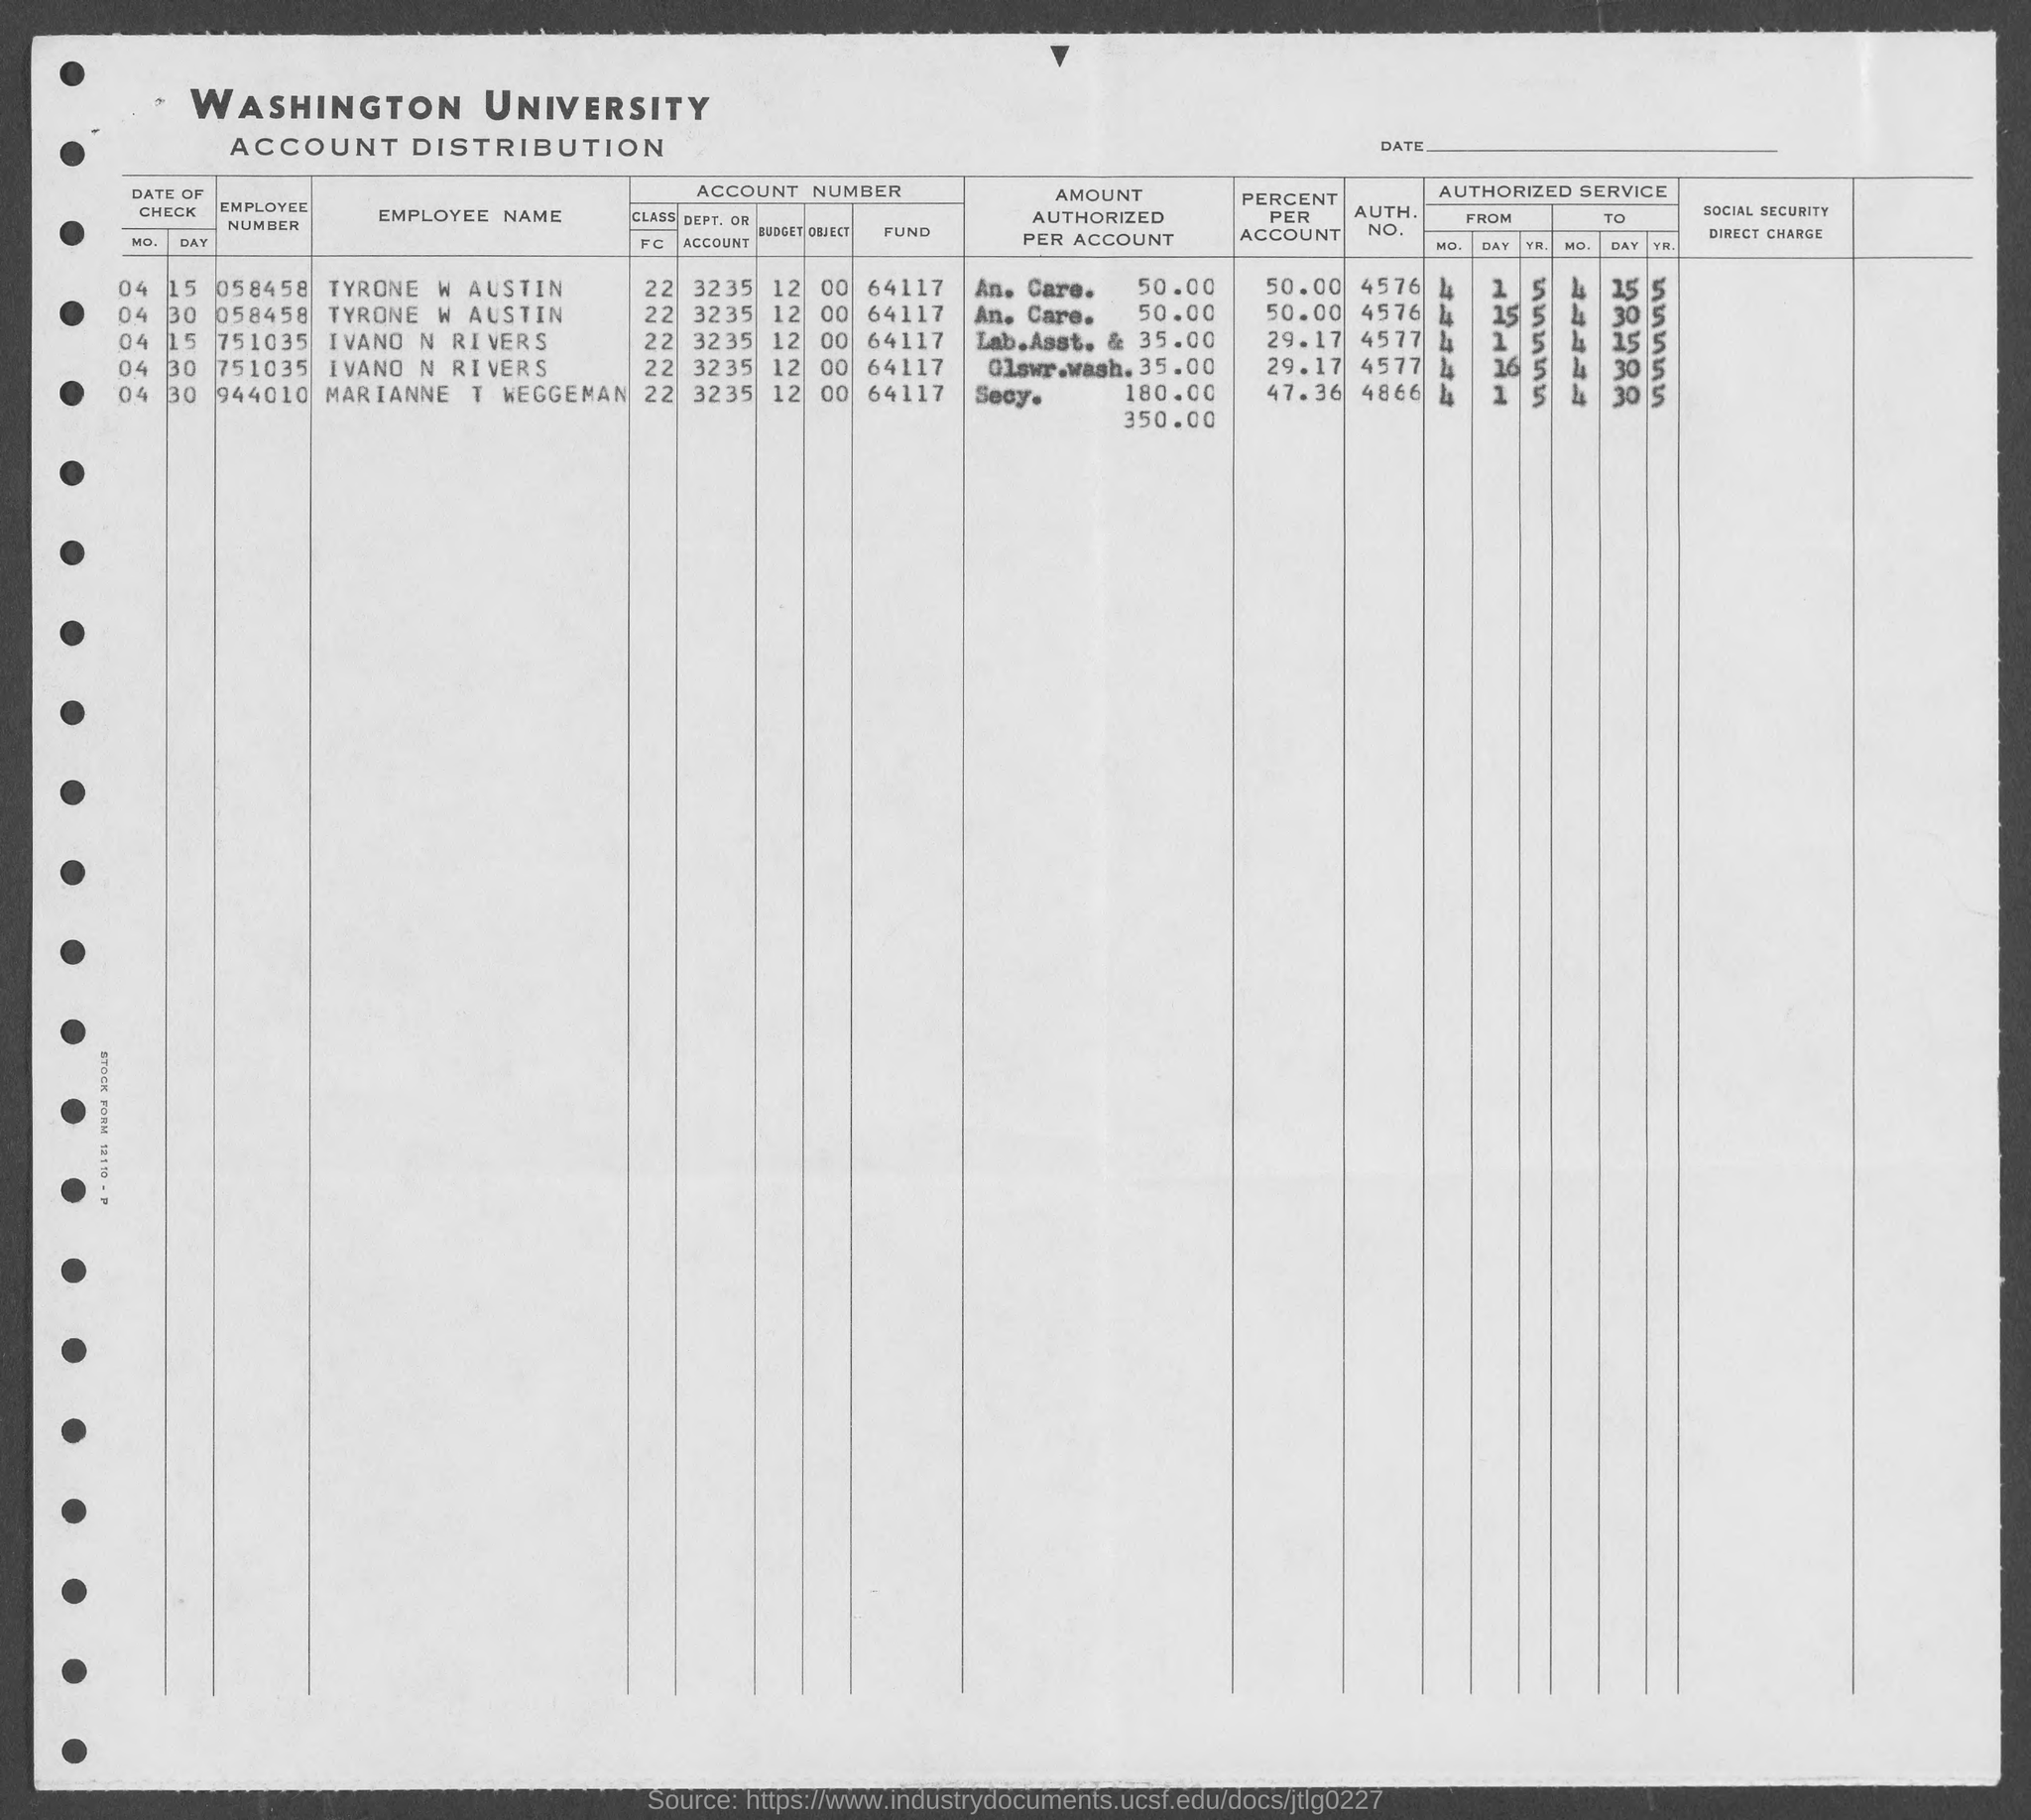Point out several critical features in this image. The employee number provided for Tyrone W Austin is 058458... as stated in the form. The employee name for employee number 058458, as mentioned in the given form, is TYRONE W AUSTIN. The name of the university mentioned in the provided form is Washington University. The employee number given for Marianne T Waggeman as mentioned in the provided form is 944010. 